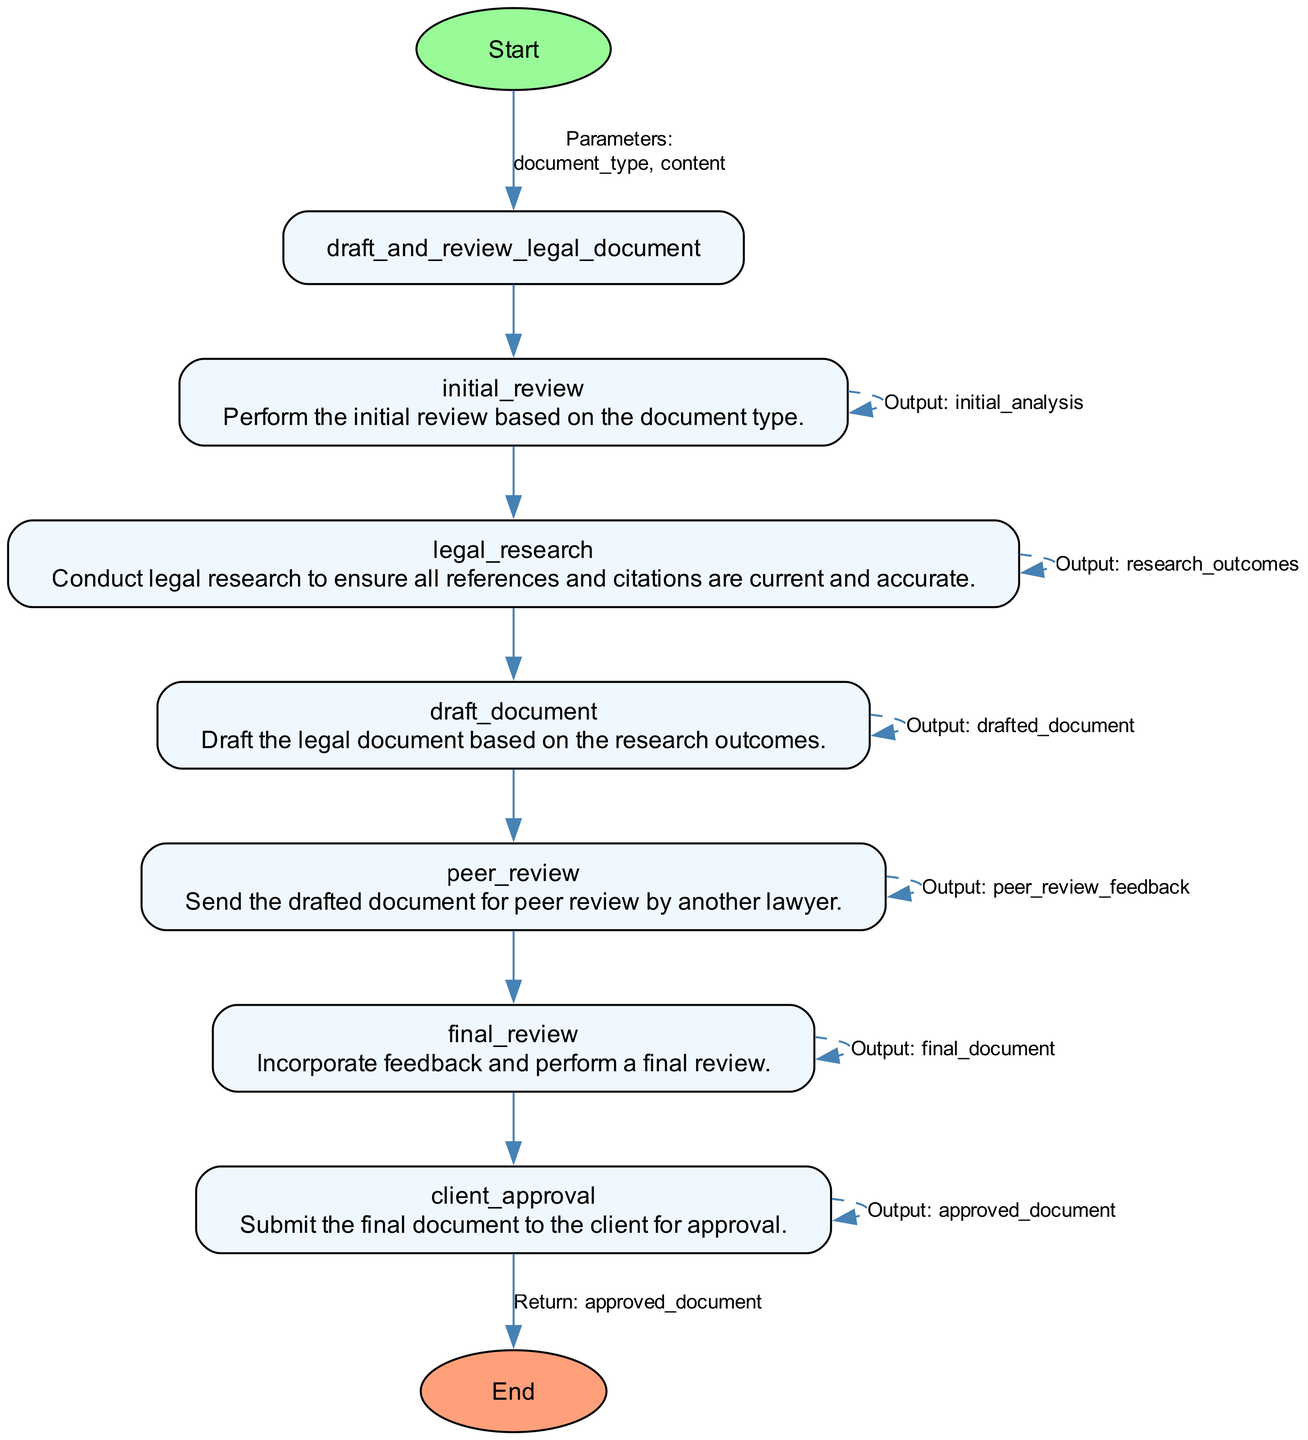What is the first step in the process? The first step in the process is the "initial review", which is the first node following the "Start" node in the flowchart.
Answer: initial review How many steps are there in total? The diagram contains six steps, which are the distinct nodes that represent the key actions in the legal document drafting and review process.
Answer: six What is the output of the "peer review" step? The output of the "peer review" step is "peer_review_feedback", which is indicated as the output in the corresponding node.
Answer: peer_review_feedback Which step incorporates feedback? The "final review" step incorporates feedback as indicated in its description, where it states that it incorporates feedback from the peer review.
Answer: final review What happens after the "draft document" step? After the "draft document" step, the next step is "peer review", which follows directly in the flow from the "draft document" node.
Answer: peer review What is the final output of the entire process? The final output of the entire process is the "approved_document" as indicated in the connection to the ending node from the last step.
Answer: approved_document Which function performs the initial review? The function that performs the initial review is "initial_review", which is specified in the description of the first step in the diagram.
Answer: initial_review What is the purpose of the "legal research" step? The purpose of the "legal research" step is to "ensure all references and citations are current and accurate," highlighting its critical function in the drafting process.
Answer: ensure all references and citations are current and accurate What type of document is reviewed and approved at the end? The document that is reviewed and approved at the end is a legal document, as indicated by the overall title and context of the process.
Answer: legal document 